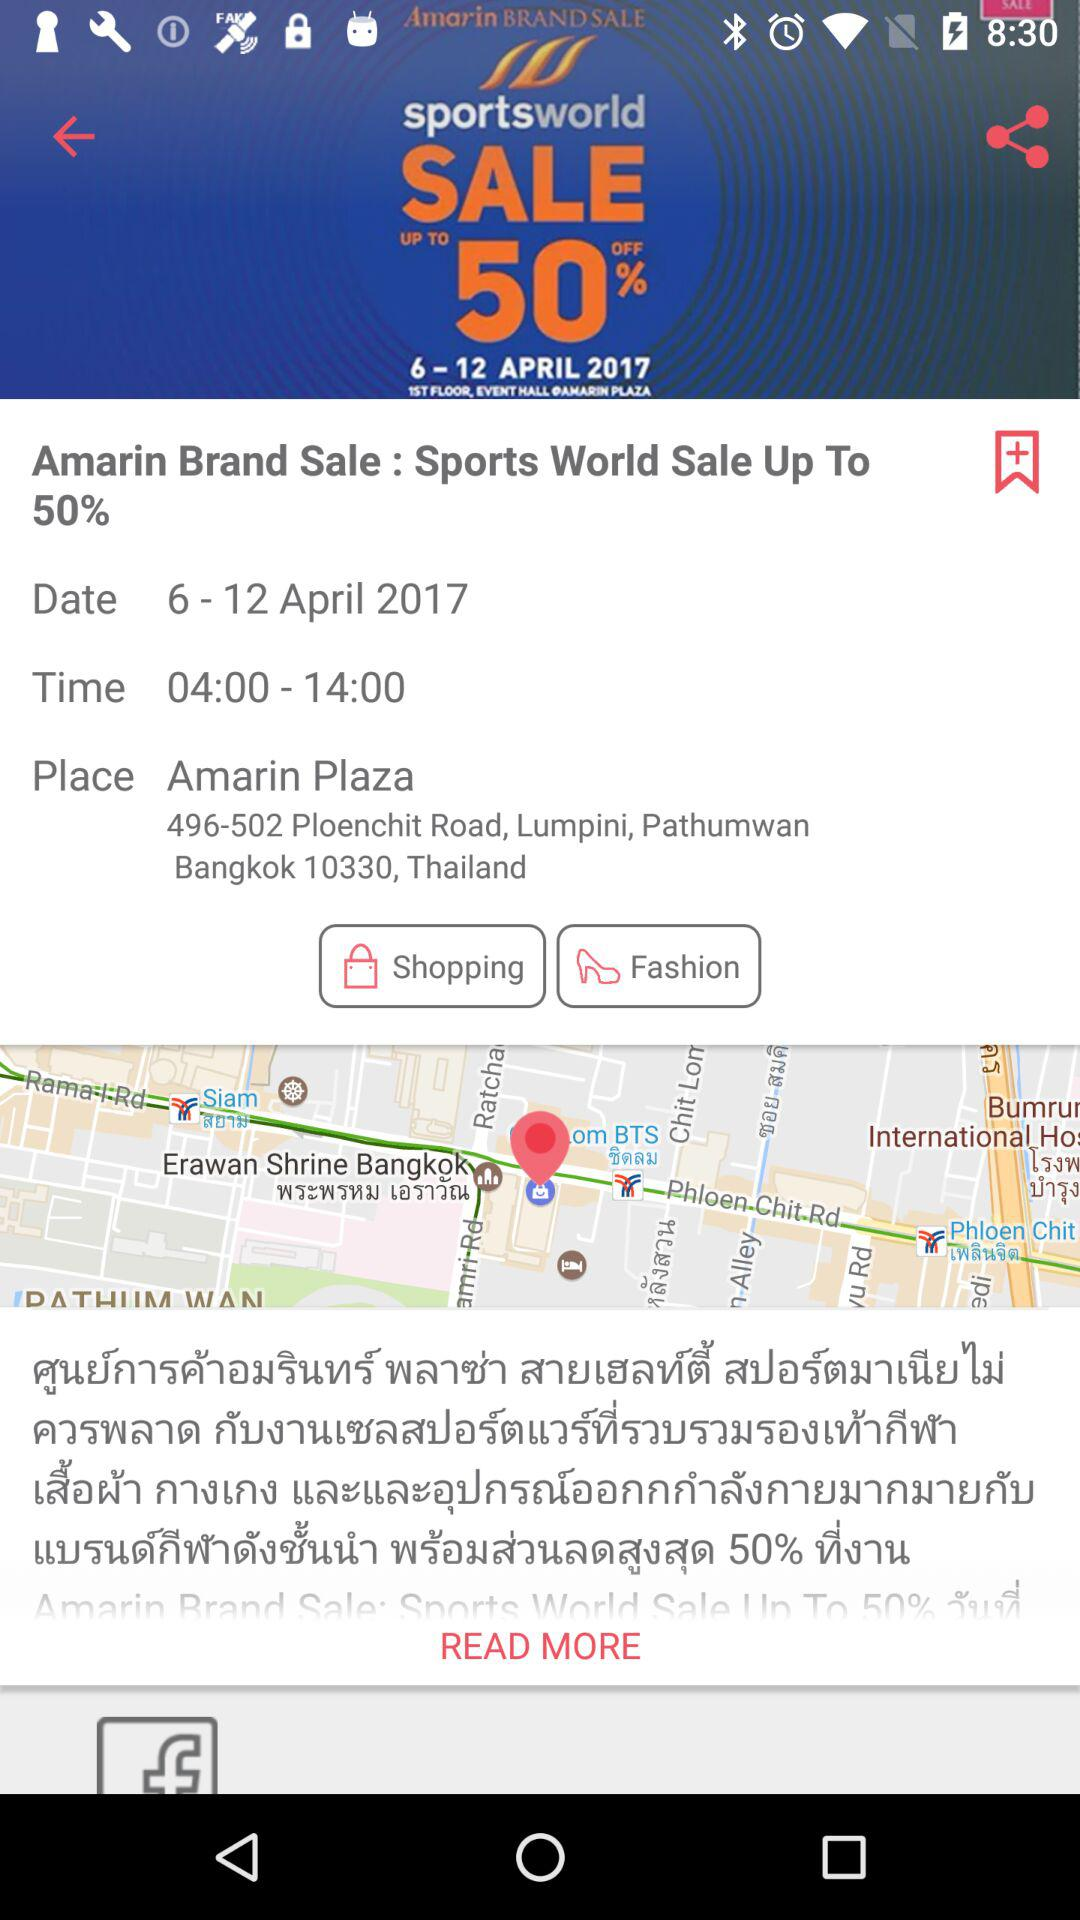What is the date range? The date range is April 6–12, 2017. 